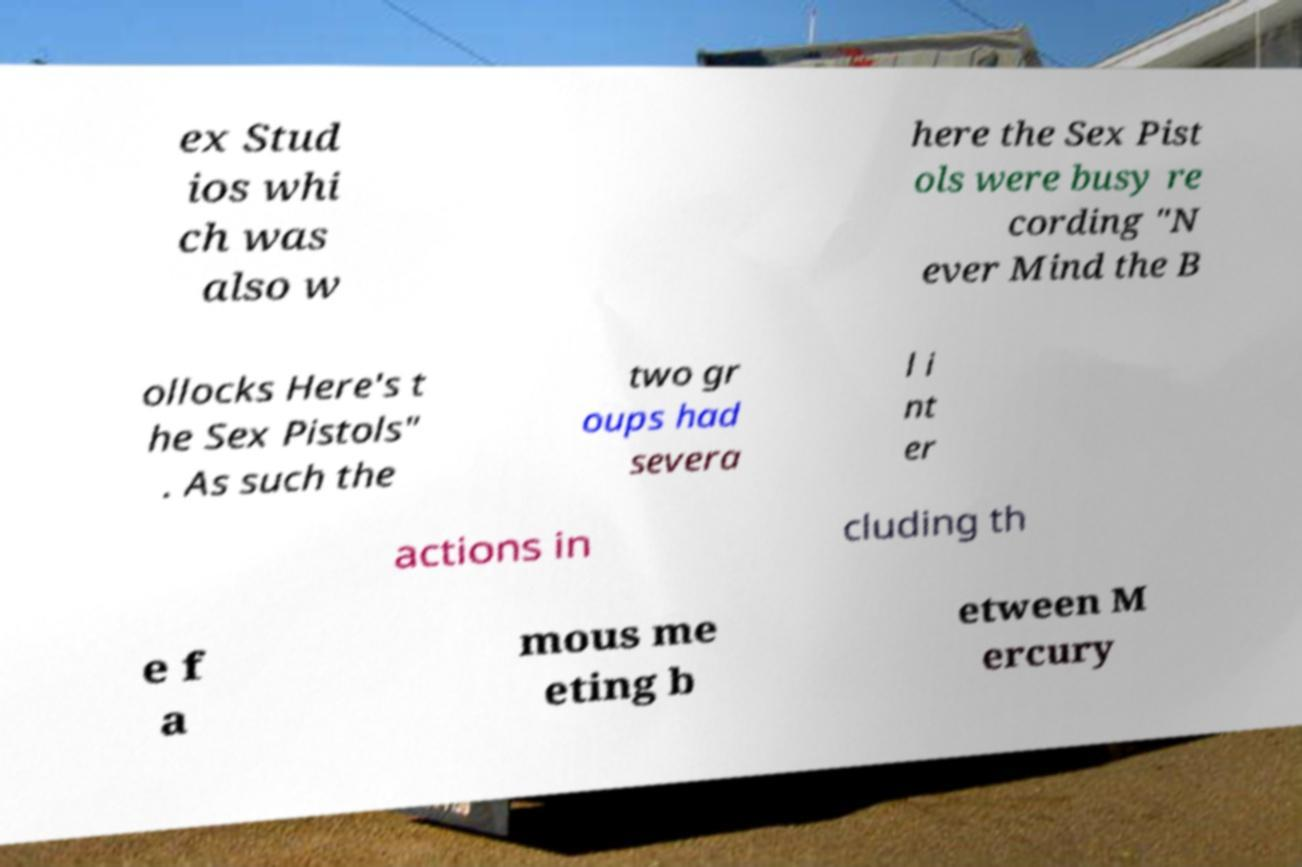Could you extract and type out the text from this image? ex Stud ios whi ch was also w here the Sex Pist ols were busy re cording "N ever Mind the B ollocks Here's t he Sex Pistols" . As such the two gr oups had severa l i nt er actions in cluding th e f a mous me eting b etween M ercury 